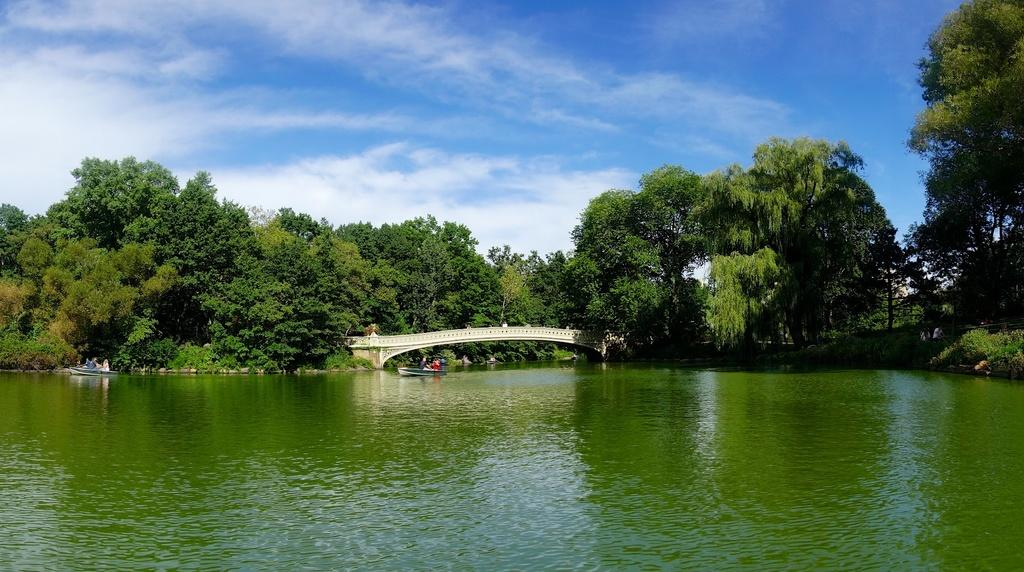What body of water is visible at the bottom of the image? There is a lake at the bottom of the image. What structure can be seen crossing the lake? There is a bridge in the image. What type of vegetation is visible in the background of the image? There are trees in the background of the image. What is the condition of the sky in the image? The sky is cloudy at the top of the image. How does the lake stretch across the image? The lake does not stretch across the image; it is a stationary body of water at the bottom of the image. What type of breath can be seen coming from the trees in the background? There is no breath visible in the image; it is a still photograph. 